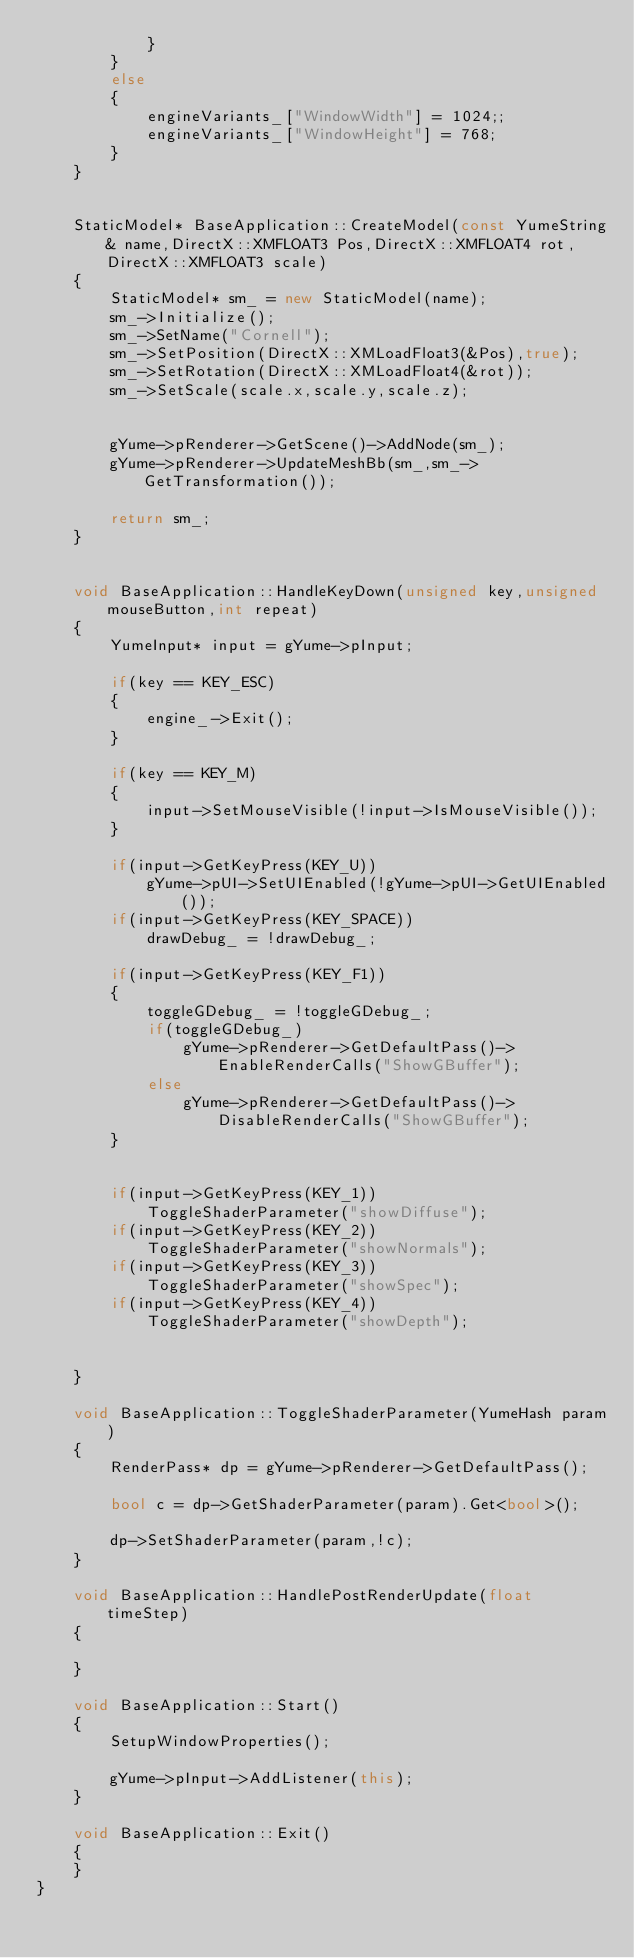<code> <loc_0><loc_0><loc_500><loc_500><_C++_>			}
		}
		else
		{
			engineVariants_["WindowWidth"] = 1024;;
			engineVariants_["WindowHeight"] = 768;
		}
	}


	StaticModel* BaseApplication::CreateModel(const YumeString& name,DirectX::XMFLOAT3 Pos,DirectX::XMFLOAT4 rot,DirectX::XMFLOAT3 scale)
	{
		StaticModel* sm_ = new StaticModel(name);
		sm_->Initialize();
		sm_->SetName("Cornell");
		sm_->SetPosition(DirectX::XMLoadFloat3(&Pos),true);
		sm_->SetRotation(DirectX::XMLoadFloat4(&rot));
		sm_->SetScale(scale.x,scale.y,scale.z);


		gYume->pRenderer->GetScene()->AddNode(sm_);
		gYume->pRenderer->UpdateMeshBb(sm_,sm_->GetTransformation());

		return sm_;
	}


	void BaseApplication::HandleKeyDown(unsigned key,unsigned mouseButton,int repeat)
	{
		YumeInput* input = gYume->pInput;

		if(key == KEY_ESC)
		{
			engine_->Exit();
		}

		if(key == KEY_M)
		{
			input->SetMouseVisible(!input->IsMouseVisible());
		}

		if(input->GetKeyPress(KEY_U))
			gYume->pUI->SetUIEnabled(!gYume->pUI->GetUIEnabled());
		if(input->GetKeyPress(KEY_SPACE))
			drawDebug_ = !drawDebug_;

		if(input->GetKeyPress(KEY_F1))
		{
			toggleGDebug_ = !toggleGDebug_;
			if(toggleGDebug_)
				gYume->pRenderer->GetDefaultPass()->EnableRenderCalls("ShowGBuffer");
			else
				gYume->pRenderer->GetDefaultPass()->DisableRenderCalls("ShowGBuffer");
		}


		if(input->GetKeyPress(KEY_1))
			ToggleShaderParameter("showDiffuse");
		if(input->GetKeyPress(KEY_2))
			ToggleShaderParameter("showNormals");
		if(input->GetKeyPress(KEY_3))
			ToggleShaderParameter("showSpec");
		if(input->GetKeyPress(KEY_4))
			ToggleShaderParameter("showDepth");


	}

	void BaseApplication::ToggleShaderParameter(YumeHash param)
	{
		RenderPass* dp = gYume->pRenderer->GetDefaultPass();

		bool c = dp->GetShaderParameter(param).Get<bool>();

		dp->SetShaderParameter(param,!c);
	}

	void BaseApplication::HandlePostRenderUpdate(float timeStep)
	{

	}

	void BaseApplication::Start()
	{
		SetupWindowProperties();

		gYume->pInput->AddListener(this);
	}

	void BaseApplication::Exit()
	{
	}
}
</code> 